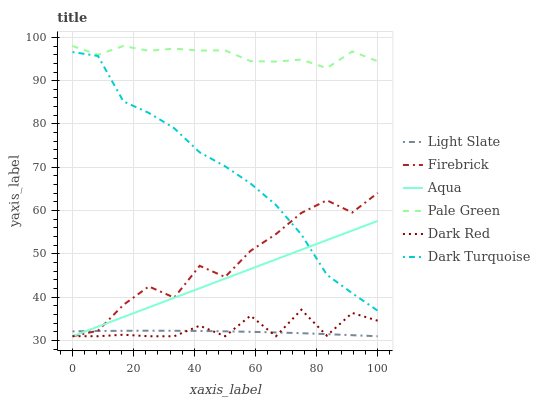Does Dark Red have the minimum area under the curve?
Answer yes or no. No. Does Dark Red have the maximum area under the curve?
Answer yes or no. No. Is Firebrick the smoothest?
Answer yes or no. No. Is Firebrick the roughest?
Answer yes or no. No. Does Pale Green have the lowest value?
Answer yes or no. No. Does Dark Red have the highest value?
Answer yes or no. No. Is Dark Turquoise less than Pale Green?
Answer yes or no. Yes. Is Dark Turquoise greater than Light Slate?
Answer yes or no. Yes. Does Dark Turquoise intersect Pale Green?
Answer yes or no. No. 